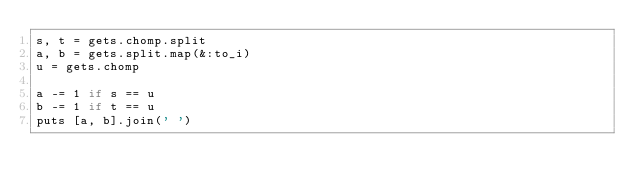<code> <loc_0><loc_0><loc_500><loc_500><_Ruby_>s, t = gets.chomp.split
a, b = gets.split.map(&:to_i)
u = gets.chomp

a -= 1 if s == u
b -= 1 if t == u
puts [a, b].join(' ')</code> 